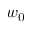<formula> <loc_0><loc_0><loc_500><loc_500>w _ { 0 }</formula> 